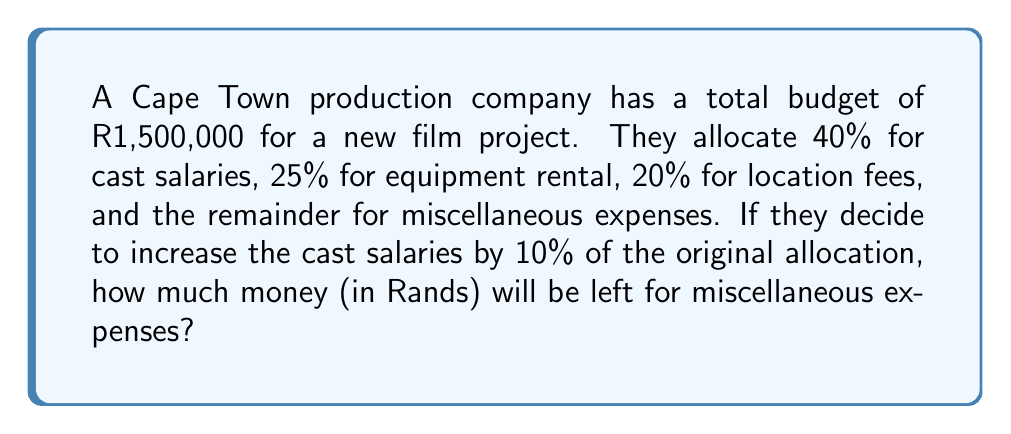Could you help me with this problem? Let's break this down step-by-step:

1. Calculate the original allocations:
   Cast salaries: $0.40 \times \text{R}1,500,000 = \text{R}600,000$
   Equipment rental: $0.25 \times \text{R}1,500,000 = \text{R}375,000$
   Location fees: $0.20 \times \text{R}1,500,000 = \text{R}300,000$

2. Calculate the original amount for miscellaneous expenses:
   $\text{R}1,500,000 - (\text{R}600,000 + \text{R}375,000 + \text{R}300,000) = \text{R}225,000$

3. Calculate the 10% increase in cast salaries:
   $0.10 \times \text{R}600,000 = \text{R}60,000$

4. Subtract the increase from the original miscellaneous expenses:
   $\text{R}225,000 - \text{R}60,000 = \text{R}165,000$

Therefore, after increasing the cast salaries by 10%, R165,000 will be left for miscellaneous expenses.
Answer: R165,000 